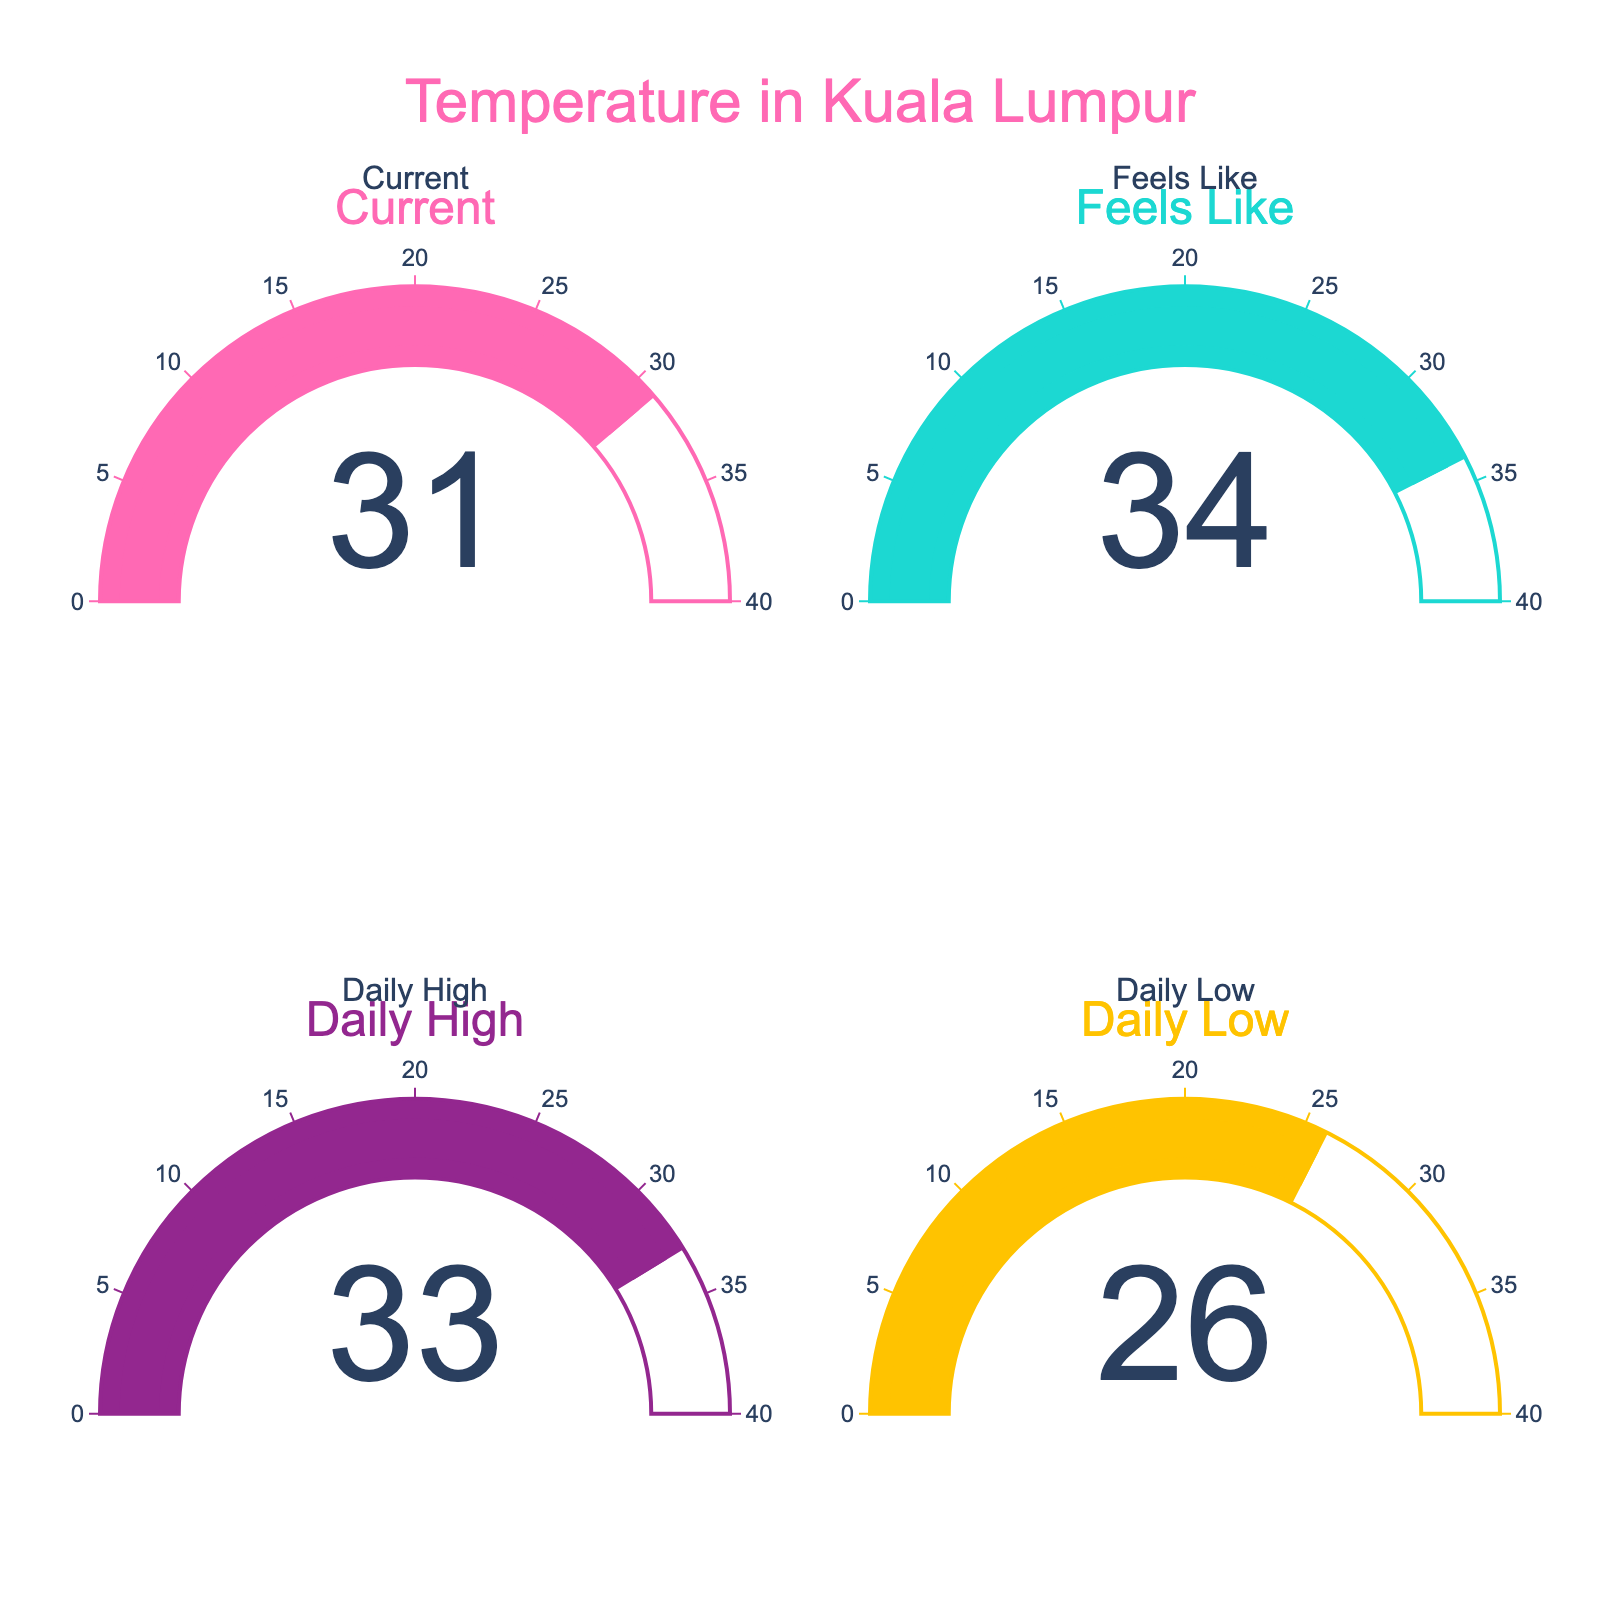What's the current temperature in Kuala Lumpur? The gauge chart for "Current" shows the temperature reading specifically for Kuala Lumpur.
Answer: 31°C Which temperature value is the highest displayed on the gauge charts? By examining the gauges, we can see that the "Feels Like" gauge is the highest among the displayed values.
Answer: 34°C How much higher is the 'Feels Like' temperature compared to the actual current temperature? Subtract the current temperature (31°C) from the 'Feels Like' temperature (34°C): 34 - 31.
Answer: 3°C What is the difference between the daily high temperature and the daily low temperature? Subtract the daily low temperature (26°C) from the daily high temperature (33°C): 33 - 26.
Answer: 7°C Is the daily high temperature higher or lower than the 'Feels Like' temperature? Compare the values displayed on the gauges: daily high is 33°C and 'Feels Like' is 34°C.
Answer: Lower How many different temperature metrics are shown in the figure? Count the unique labels on the gauge charts: Current, Feels Like, Daily High, Daily Low.
Answer: 4 What is the range of the daily temperature in Kuala Lumpur? The range is determined by the daily low and daily high temperatures: 26°C to 33°C.
Answer: 26°C to 33°C 